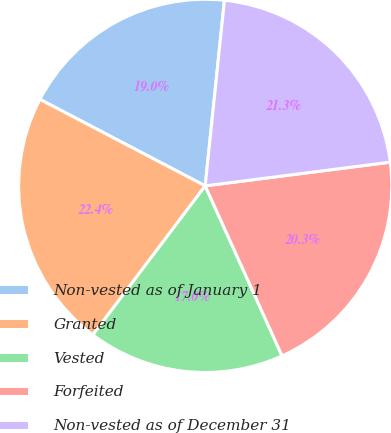Convert chart. <chart><loc_0><loc_0><loc_500><loc_500><pie_chart><fcel>Non-vested as of January 1<fcel>Granted<fcel>Vested<fcel>Forfeited<fcel>Non-vested as of December 31<nl><fcel>18.97%<fcel>22.39%<fcel>17.04%<fcel>20.27%<fcel>21.33%<nl></chart> 